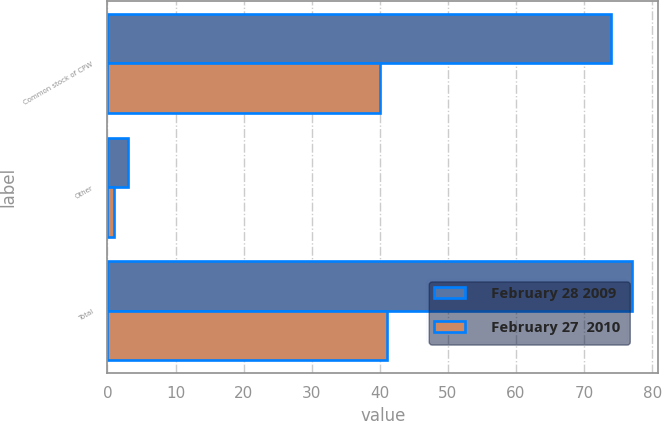Convert chart. <chart><loc_0><loc_0><loc_500><loc_500><stacked_bar_chart><ecel><fcel>Common stock of CPW<fcel>Other<fcel>Total<nl><fcel>February 28 2009<fcel>74<fcel>3<fcel>77<nl><fcel>February 27  2010<fcel>40<fcel>1<fcel>41<nl></chart> 